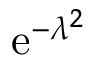Convert formula to latex. <formula><loc_0><loc_0><loc_500><loc_500>e ^ { - \lambda ^ { 2 } }</formula> 